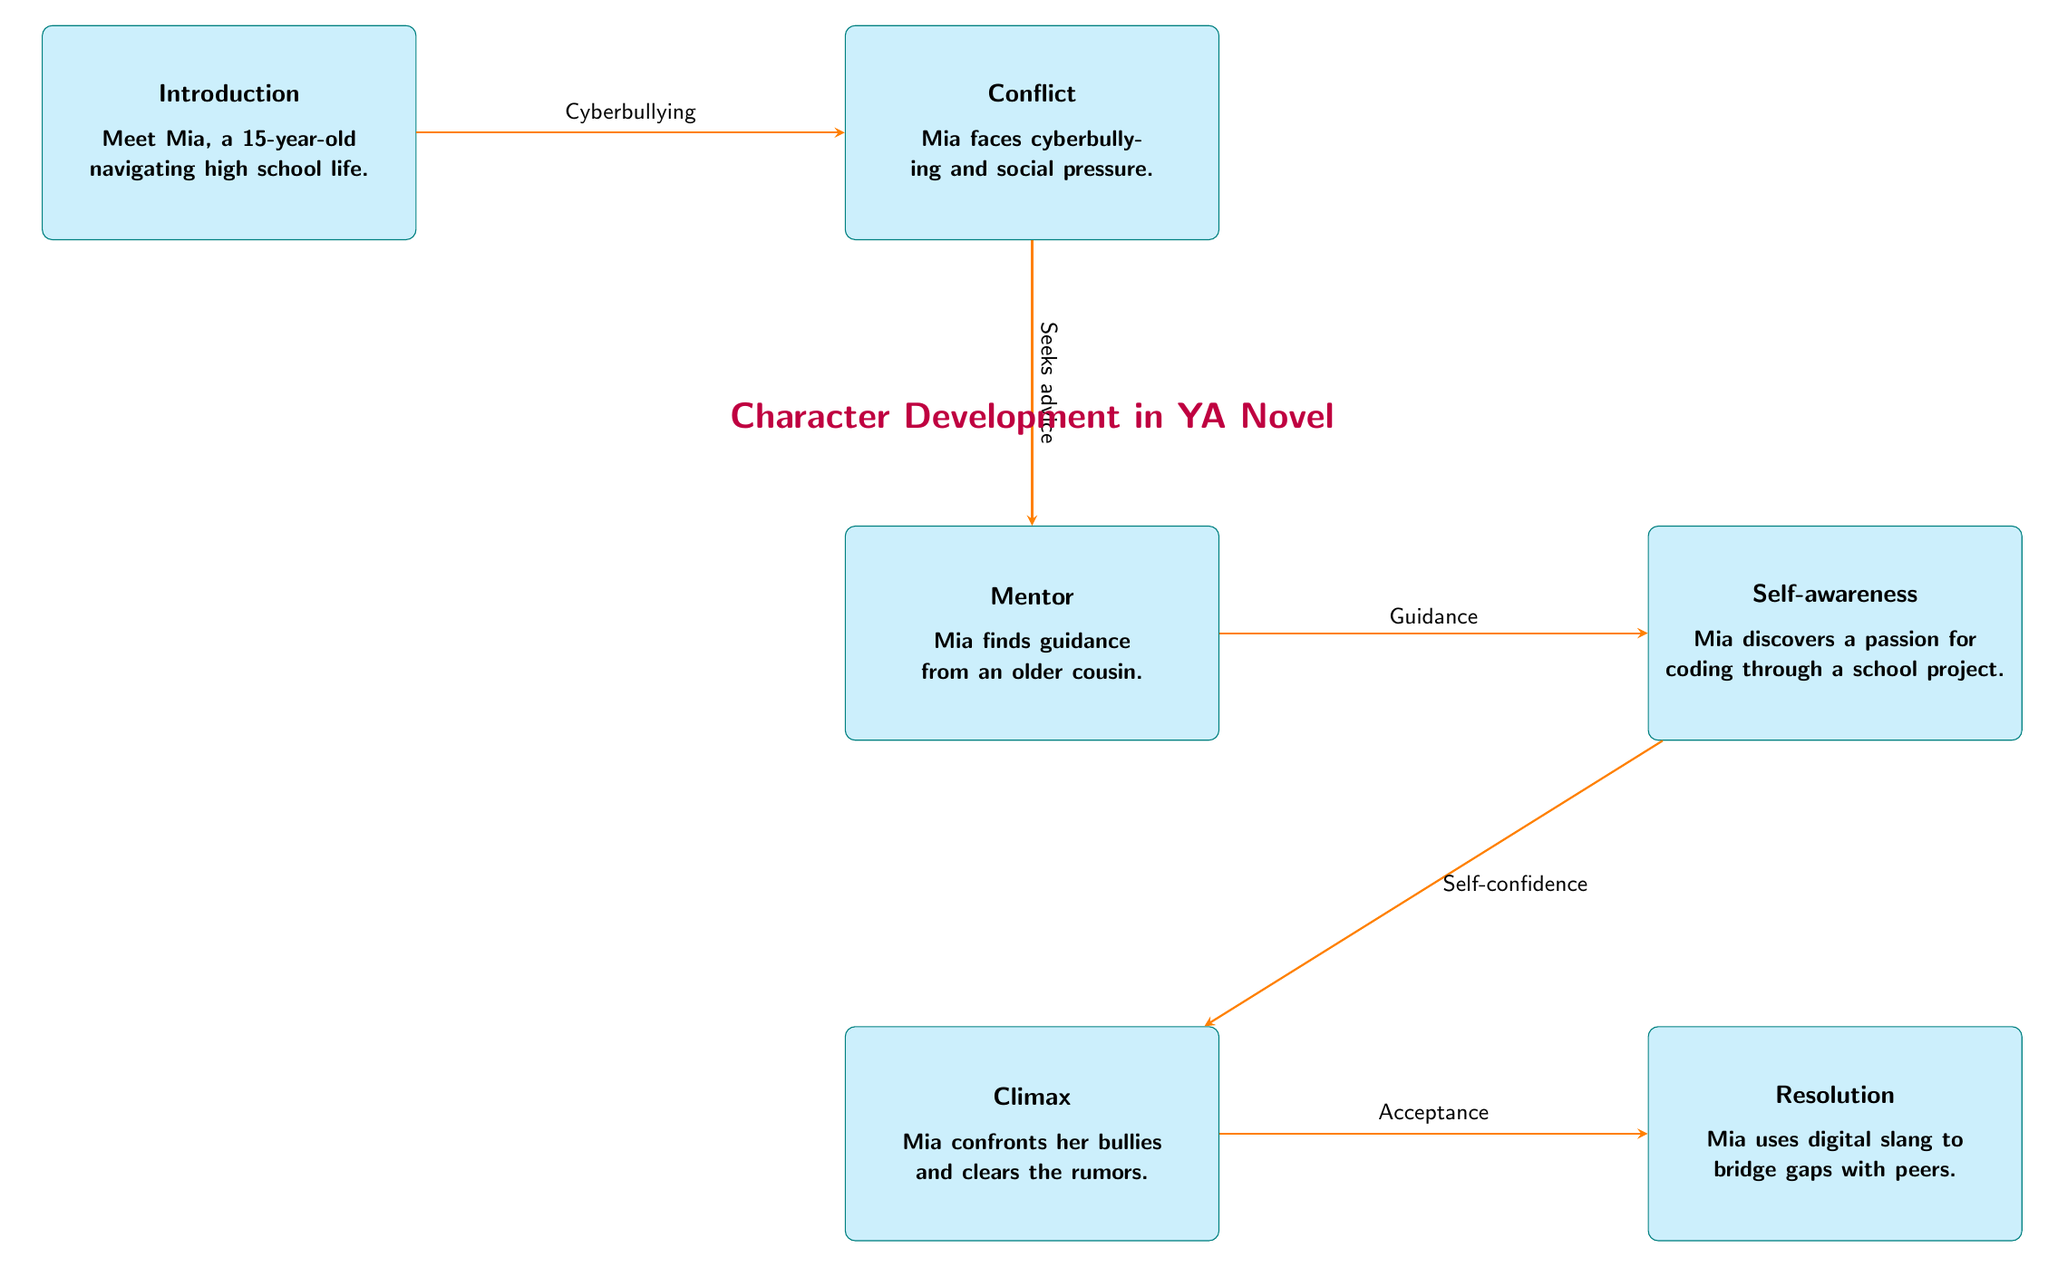What is the primary conflict in the story? The diagram indicates that the primary conflict is cyberbullying faced by the protagonist, Mia. This is clearly stated in the "Conflict" node of the flowchart.
Answer: Cyberbullying Who provides guidance to Mia? According to the diagram, Mia receives guidance from her older cousin, who is labeled as the "Mentor" in the flowchart.
Answer: Older cousin How many key nodes are in the diagram? The diagram consists of six key nodes: Introduction, Conflict, Mentor, Self-awareness, Climax, and Resolution, thus there are six nodes in total.
Answer: Six What does Mia discover about herself during her journey? The "Self-awareness" node specifies that Mia discovers a passion for coding, which highlights her personal growth throughout the story.
Answer: Passion for coding What major event occurs after Mia seeks advice? The diagram illustrates that after seeking advice from her mentor, she experiences "Guidance," which leads her toward the path of self-awareness and is essential for her development.
Answer: Guidance Which node follows the Climax in the sequence? The flow of the diagram shows that the "Resolution" node follows the "Climax," indicating that she resolves the issues after confronting her bullies.
Answer: Resolution How does Mia use digital slang in her journey? The "Resolution" node describes that Mia uses digital slang to bridge gaps with her peers, highlighting the significance of communication and connection in her character development.
Answer: To bridge gaps What type of character development does Mia undergo after self-awareness? After the "Self-awareness" node, Mia gains "Self-confidence," indicating that this reflection process enhances her personal growth and resilience.
Answer: Self-confidence What is the central theme highlighted through Mia's progression? The flowchart emphasizes a central theme of addressing and overcoming challenges like cyberbullying through personal growth, mentorship, and communication, particularly with digital slang.
Answer: Overcoming challenges 